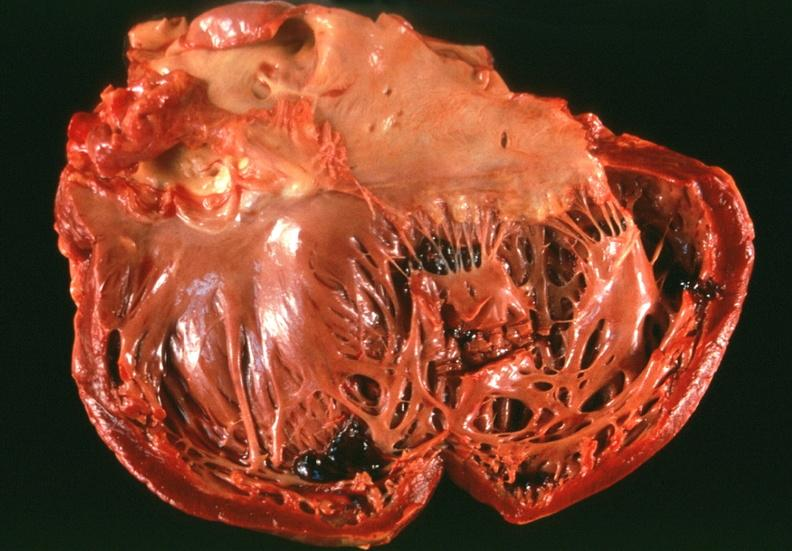where is this?
Answer the question using a single word or phrase. Heart 